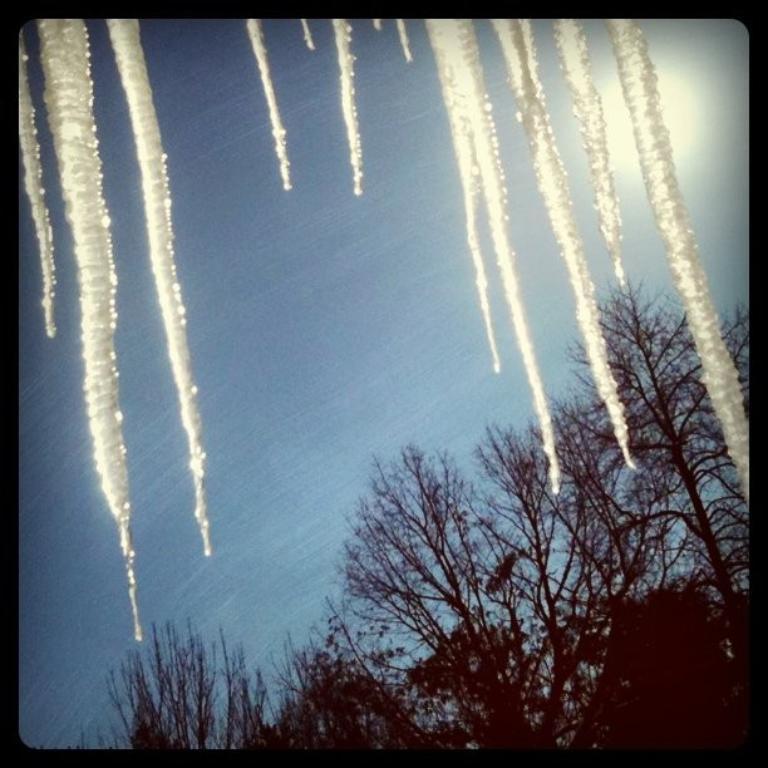Could you give a brief overview of what you see in this image? In this image in front there is a glass window with ice on it. Through glass window we can see trees and sky. 